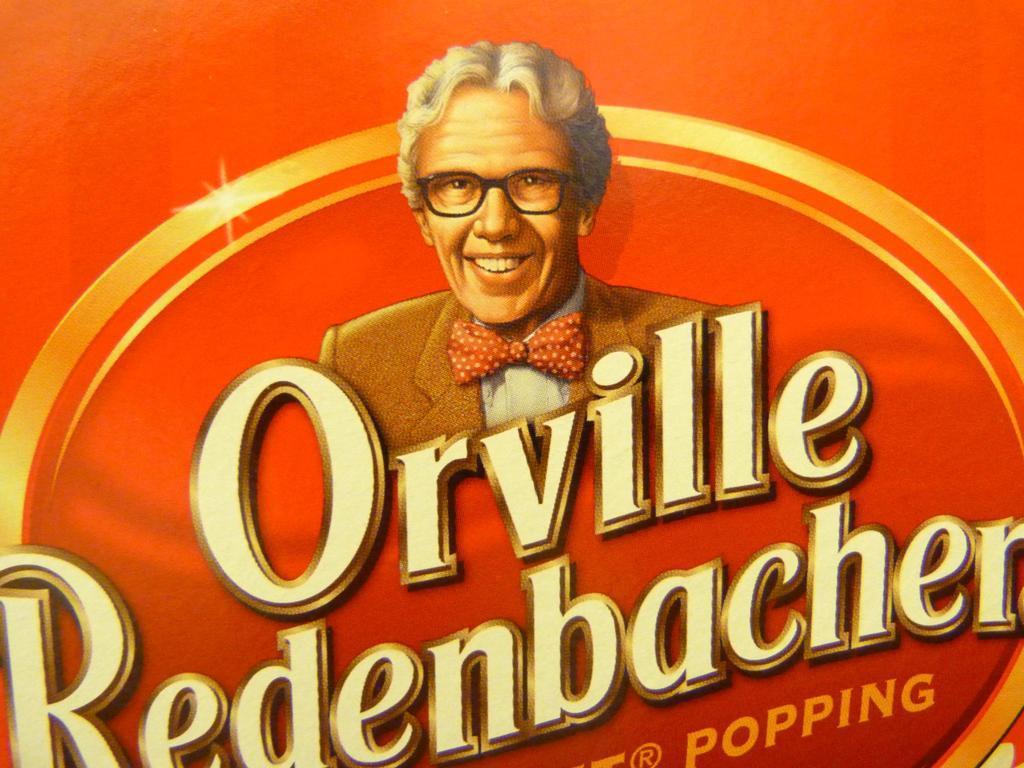Could you give a brief overview of what you see in this image? In this picture, we can see a poster with some text and an image on it. 